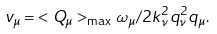Convert formula to latex. <formula><loc_0><loc_0><loc_500><loc_500>v _ { \mu } = { < { Q } _ { \mu } > _ { \max } \omega _ { \mu } } / { 2 k _ { \nu } ^ { 2 } q _ { \nu } ^ { 2 } q _ { \mu } } .</formula> 